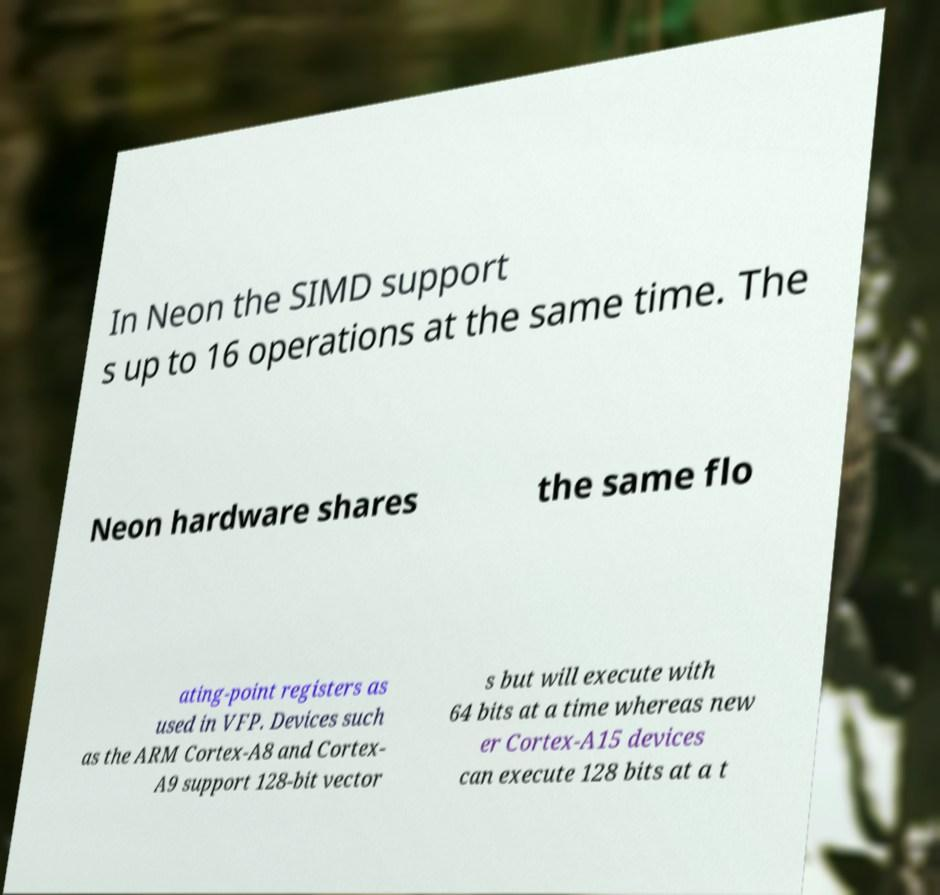Can you accurately transcribe the text from the provided image for me? In Neon the SIMD support s up to 16 operations at the same time. The Neon hardware shares the same flo ating-point registers as used in VFP. Devices such as the ARM Cortex-A8 and Cortex- A9 support 128-bit vector s but will execute with 64 bits at a time whereas new er Cortex-A15 devices can execute 128 bits at a t 